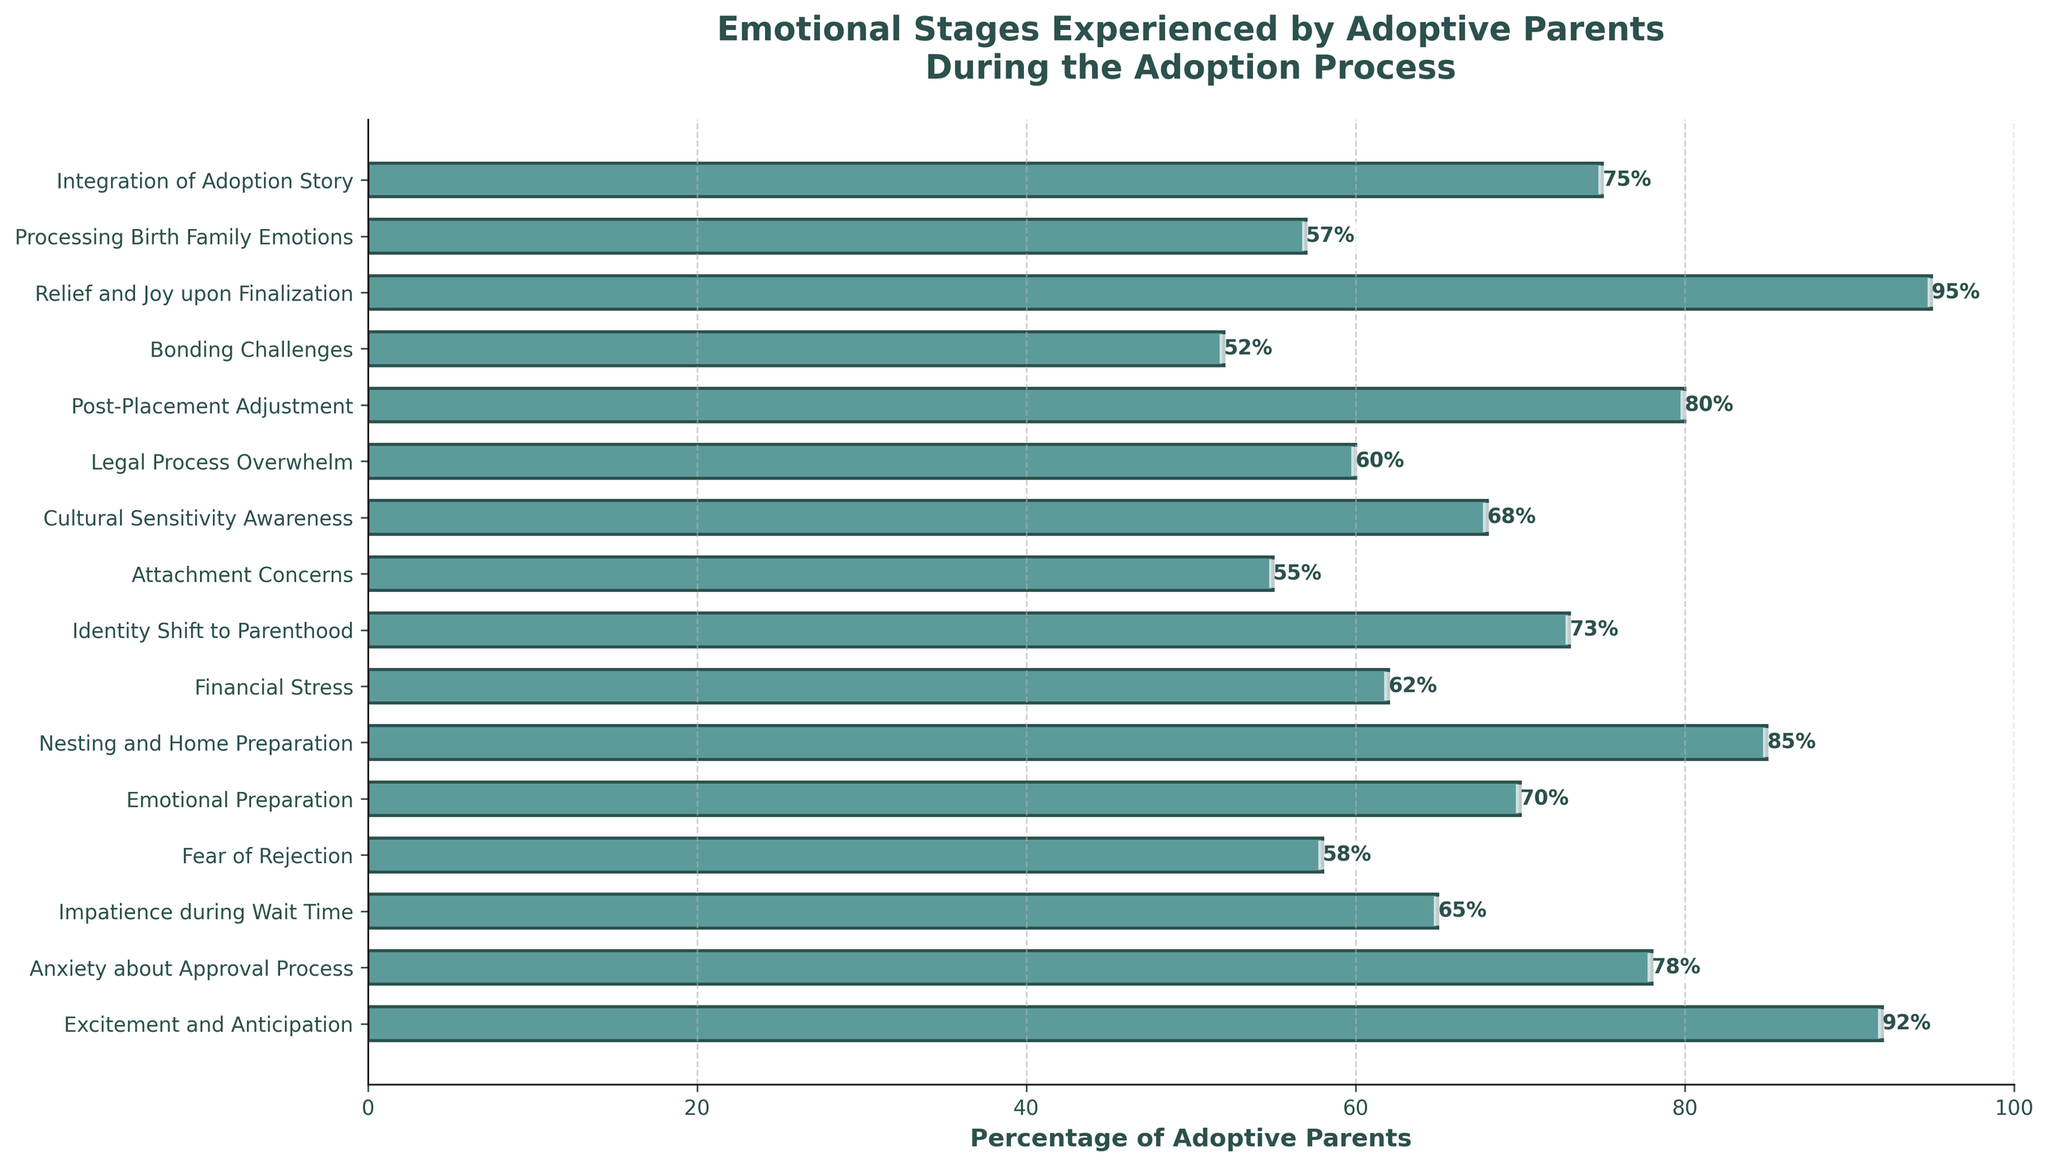Which emotional stage do the most adoptive parents experience? Look for the bar that extends the farthest to the right, representing the highest percentage. "Relief and Joy upon Finalization" has the highest percentage at 95%.
Answer: Relief and Joy upon Finalization What is the percentage difference between the stages "Nesting and Home Preparation" and "Legal Process Overwhelm"? Subtract the percentage of "Legal Process Overwhelm" from the percentage of "Nesting and Home Preparation": 85% - 60% = 25%.
Answer: 25% Which stages have percentages that are greater than 70%? Identify the bars that extend beyond the 70% mark. These stages are "Excitement and Anticipation" (92%), "Nesting and Home Preparation" (85%), "Post-Placement Adjustment" (80%), "Relief and Joy upon Finalization" (95%), and "Integration of Adoption Story" (75%).
Answer: Excitement and Anticipation, Nesting and Home Preparation, Post-Placement Adjustment, Relief and Joy upon Finalization, Integration of Adoption Story How many stages have a percentage less than or equal to 60%? Count the bars whose lengths do not exceed the 60% mark. These stages are "Fear of Rejection" (58%), "Attachment Concerns" (55%), "Legal Process Overwhelm" (60%), and "Bonding Challenges" (52%). In total, there are 4 such stages.
Answer: 4 What is the average percentage for the stages "Financial Stress", "Anxiety about Approval Process", and "Fear of Rejection"? Sum the percentages of these stages and divide by the number of stages: (62% + 78% + 58%) / 3 = 198% / 3 = 66%.
Answer: 66% Which stage comes immediately after "Emotional Preparation" in the chart? Look for the stage listed right after "Emotional Preparation" in the horizontal bar chart; it is "Nesting and Home Preparation".
Answer: Nesting and Home Preparation Are there more stages with percentages above or below 70%? Count the stages: Above 70% stages are "Excitement and Anticipation" (92%), "Nesting and Home Preparation" (85%), "Post-Placement Adjustment" (80%), "Relief and Joy upon Finalization" (95%), "Integration of Adoption Story" (75%), equating to 5 stages. Below 70% stages are "Anxiety about Approval Process" (78%), "Impatience during Wait Time" (65%), "Fear of Rejection" (58%), "Financial Stress" (62%), "Identity Shift to Parenthood" (73%), "Attachment Concerns" (55%), "Cultural Sensitivity Awareness" (68%), "Legal Process Overwhelm" (60%), "Bonding Challenges" (52%), "Processing Birth Family Emotions" (57%), equating to 11 stages.
Answer: Below What's the median percentage value of the emotional stages? To find the median, list the percentages in ascending order and find the middle value. In ascending order: 52, 55, 57, 58, 60, 62, 65, 68, 70, 73, 75, 78, 80, 85, 92, 95. The middle (8th and 9th values) are 68 and 70, so the median is (68+70)/2 = 69.
Answer: 69% Is "Identity Shift to Parenthood" experienced by more or less parents than "Integration of Adoption Story"? Compare the percentages of these stages. "Identity Shift to Parenthood" (73%) vs. "Integration of Adoption Story" (75%). 73% is less than 75%.
Answer: Less 